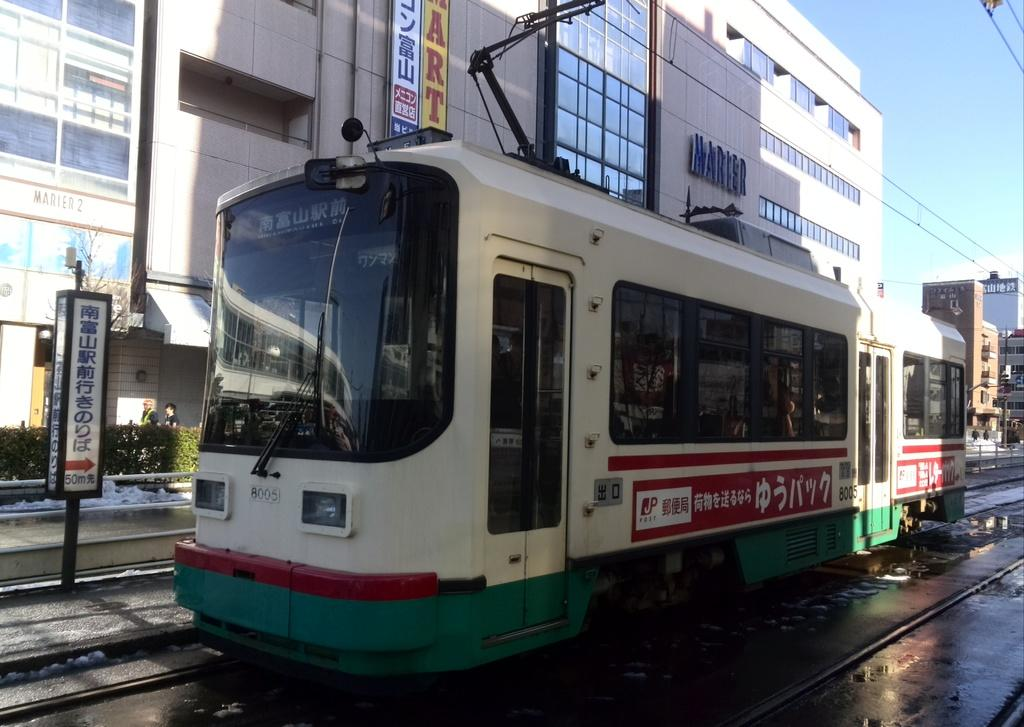What is the main subject of the picture? The main subject of the picture is an electric locomotive. What is the locomotive doing in the picture? The locomotive is moving on a track. What can be seen in the background of the picture? There are buildings and a clear sky in the background of the picture. What type of songs can be heard coming from the locomotive in the image? There is no indication in the image that the locomotive is playing or producing any songs, so it's not possible to determine what, if any, songs might be heard. 